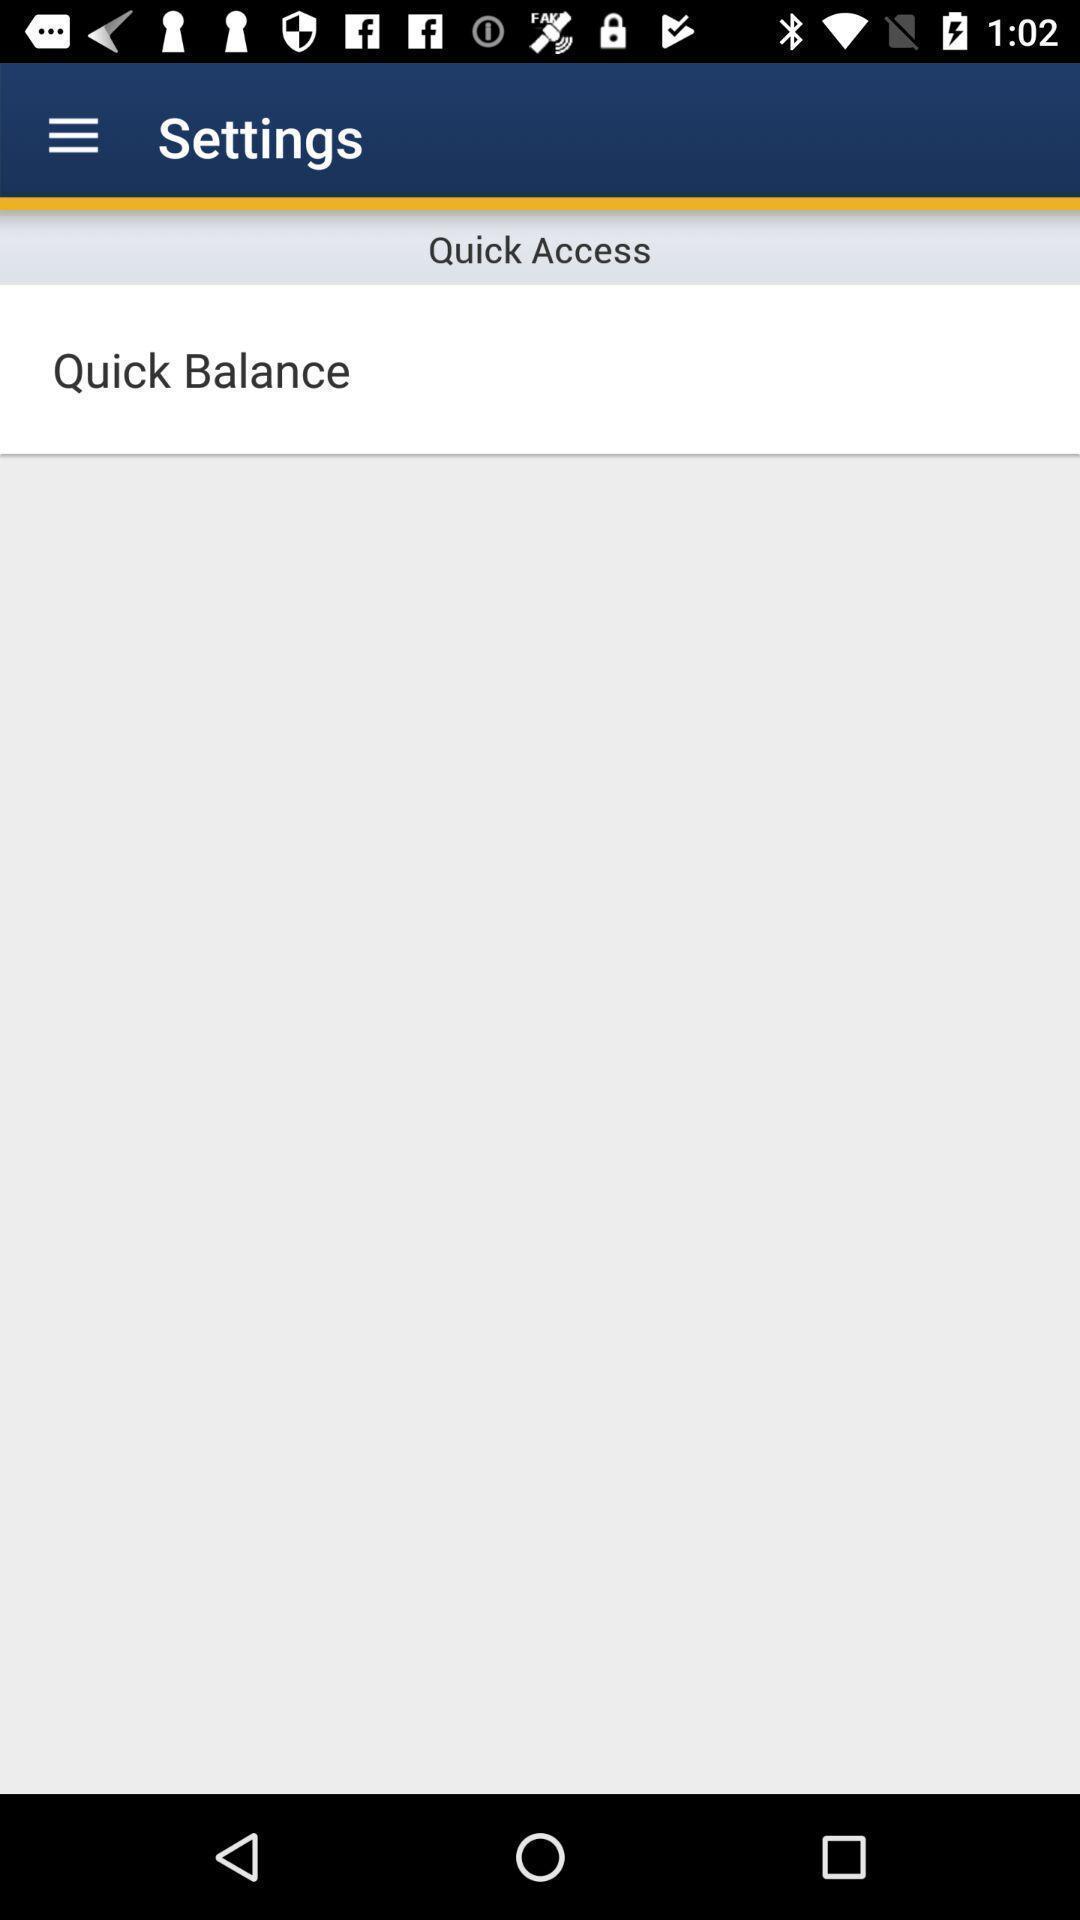Provide a description of this screenshot. Settings page for a mobile banking app. 